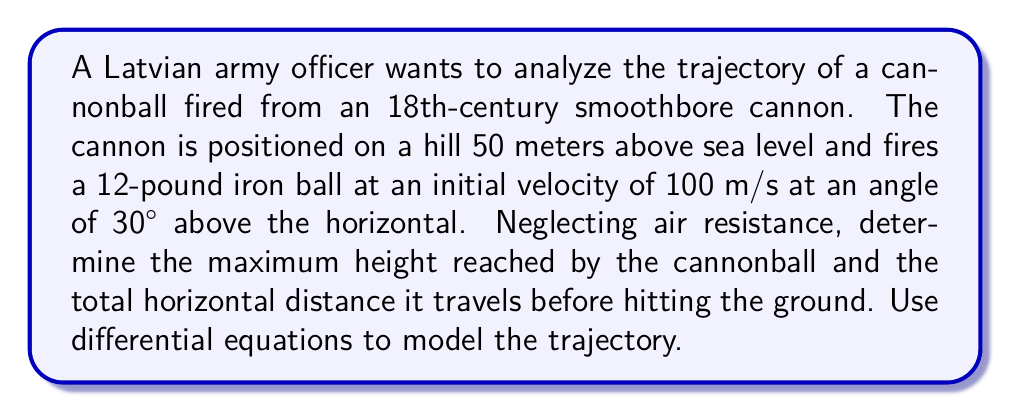Help me with this question. Let's approach this problem step-by-step using differential equations:

1) First, we'll set up our coordinate system. Let x be the horizontal distance and y be the vertical distance, with the origin at the cannon's position.

2) The equations of motion for the cannonball are:

   $$\frac{d^2x}{dt^2} = 0$$
   $$\frac{d^2y}{dt^2} = -g$$

   where g is the acceleration due to gravity (9.8 m/s²).

3) Integrating these equations once, we get:

   $$\frac{dx}{dt} = v_0 \cos\theta$$
   $$\frac{dy}{dt} = v_0 \sin\theta - gt$$

   where $v_0$ is the initial velocity and $\theta$ is the launch angle.

4) Integrating again:

   $$x = (v_0 \cos\theta)t$$
   $$y = (v_0 \sin\theta)t - \frac{1}{2}gt^2 + y_0$$

   where $y_0$ is the initial height (50 m in this case).

5) To find the maximum height, we set $\frac{dy}{dt} = 0$:

   $$0 = v_0 \sin\theta - gt_{max}$$
   $$t_{max} = \frac{v_0 \sin\theta}{g}$$

6) Substituting the values ($v_0 = 100$ m/s, $\theta = 30°$):

   $$t_{max} = \frac{100 \sin(30°)}{9.8} \approx 5.1 \text{ seconds}$$

7) The maximum height is then:

   $$y_{max} = (100 \sin(30°))(5.1) - \frac{1}{2}(9.8)(5.1)^2 + 50$$
   $$y_{max} \approx 177.6 \text{ meters}$$

8) For the total horizontal distance, we need to find when y = 0:

   $$0 = (v_0 \sin\theta)t - \frac{1}{2}gt^2 + y_0$$

9) Solving this quadratic equation:

   $$t = \frac{v_0 \sin\theta \pm \sqrt{(v_0 \sin\theta)^2 + 2gy_0}}{g}$$

10) Taking the positive root (as we want the time when the ball hits the ground):

    $$t \approx 10.9 \text{ seconds}$$

11) The horizontal distance is then:

    $$x = (v_0 \cos\theta)t = (100 \cos(30°))(10.9) \approx 944.3 \text{ meters}$$
Answer: Maximum height: 177.6 m; Horizontal distance: 944.3 m 